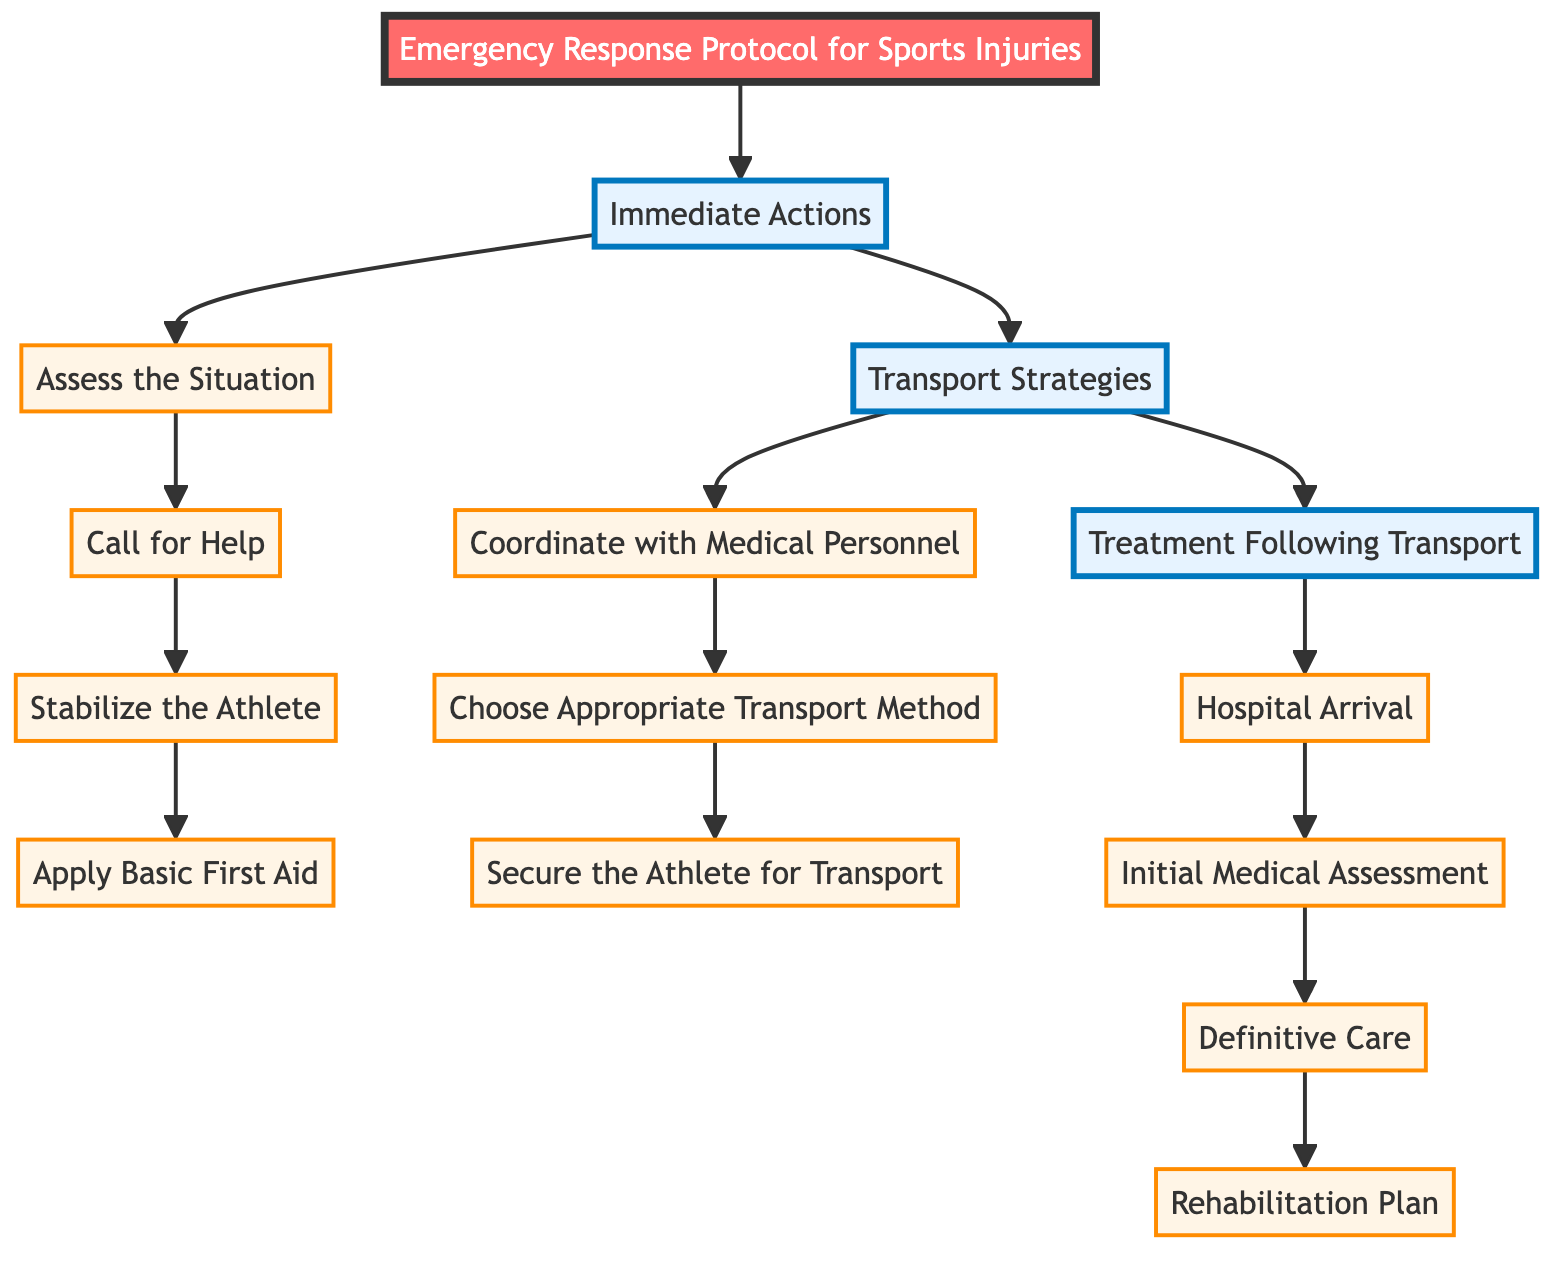What is the first step in the Immediate Actions? The diagram clearly lists "Assess the Situation" as the first step under the Immediate Actions section.
Answer: Assess the Situation How many steps are there in the Transport Strategies section? By counting the steps displayed under the Transport Strategies section, there are three listed steps.
Answer: 3 What is the final step in the Treatment Following Transport? The last step shown in the Treatment Following Transport section is "Rehabilitation Plan."
Answer: Rehabilitation Plan What step follows "Call for Help"? According to the sequence outlined in the Immediate Actions area, the step following "Call for Help" is "Stabilize the Athlete."
Answer: Stabilize the Athlete Which section comes after Immediate Actions? In the flow of the diagram, the section that follows Immediate Actions is the Transport Strategies section.
Answer: Transport Strategies What is the second step in the Immediate Actions? The second step specified in the Immediate Actions is "Call for Help."
Answer: Call for Help How many sections are in the diagram? The diagram contains three sections: Immediate Actions, Transport Strategies, and Treatment Following Transport.
Answer: 3 What is the step that involves working with paramedics? The step that discusses working with paramedics is "Coordinate with Medical Personnel."
Answer: Coordinate with Medical Personnel 